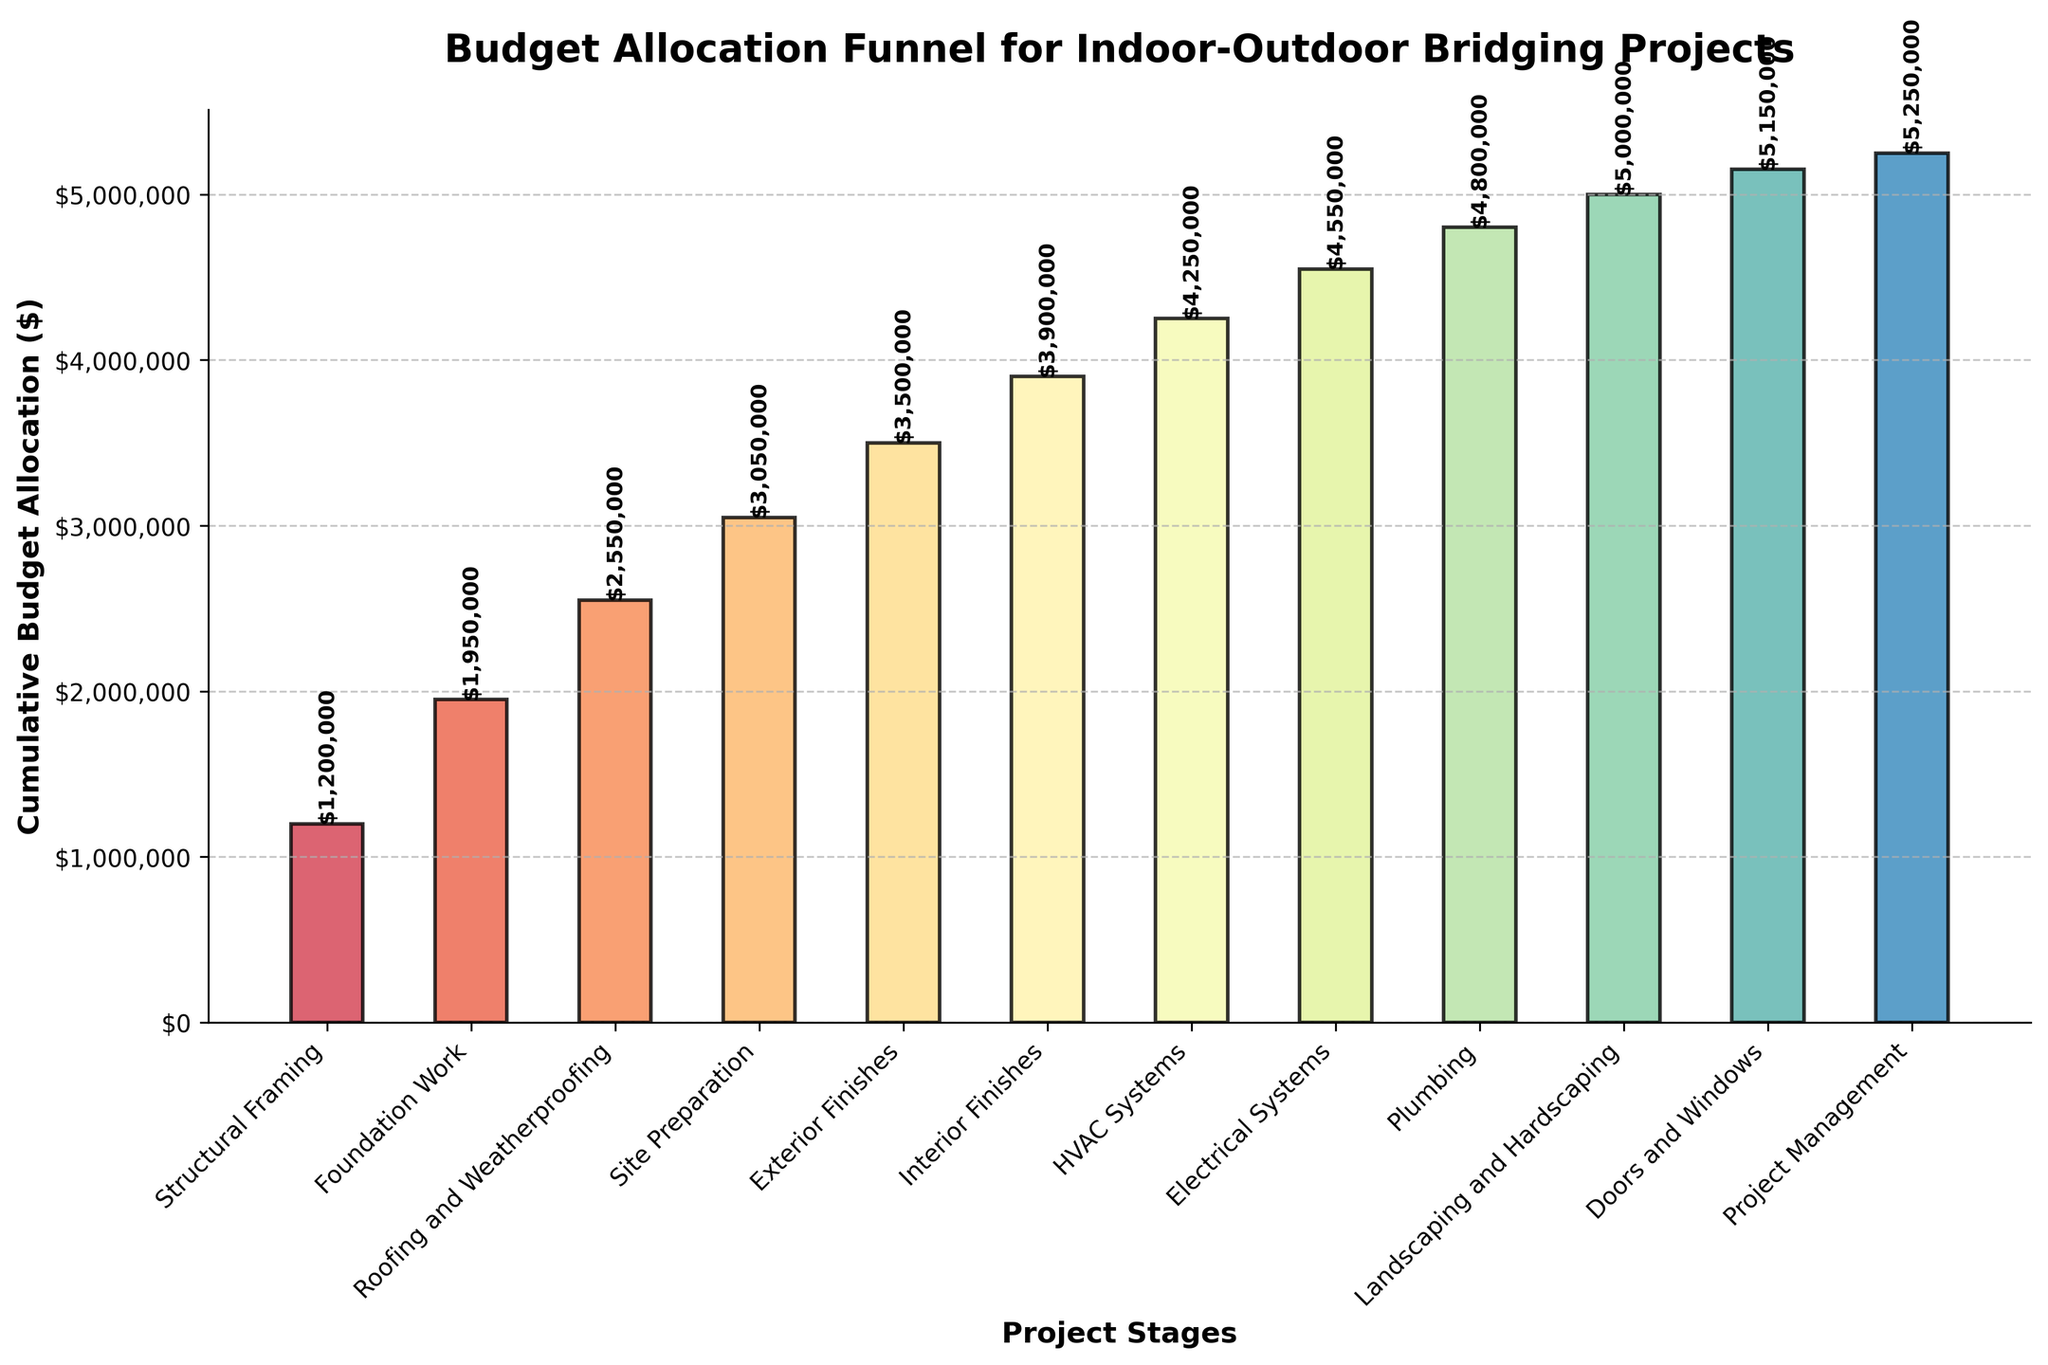What stage has the highest budget allocation? The stage with the highest budget allocation will be the first one in the sorted descending order list. From the figure, this stage is "Structural Framing".
Answer: Structural Framing What is the total budget allocation by the end of the HVAC Systems stage? To find this, sum up the cumulative budget allocations up to and including the HVAC Systems stage as represented in the bar for HVAC Systems. This sum is evident from the corresponding cumulative budget value.
Answer: $4,300,000 How does the budget allocation for Roofing and Weatherproofing compare to that for Exterior Finishes? The budget allocation for Roofing and Weatherproofing is wider and occurs earlier in the bar chart than the Exterior Finishes, indicating a higher amount.
Answer: Roofing and Weatherproofing is higher What is the title of this funnel chart? The title is displayed at the top of the chart; it reads "Budget Allocation Funnel for Indoor-Outdoor Bridging Projects".
Answer: Budget Allocation Funnel for Indoor-Outdoor Bridging Projects Which stage has the least budget allocation and what is its value? The stage with the least budget allocation is the one with the smallest bar at the bottom of the funnel, "Project Management", which has its cumulative value directly indicated in the bar text.
Answer: Project Management, $100,000 What is the cumulative budget allocation at the end of the Interior Finishes stage? Look at the cumulative budget indicated on the chart where the Interior Finishes stage bar is located. Identify the corresponding amount.
Answer: $3,900,000 How many stages are included in this budget allocation funnel? Count the number of distinct stages represented by bars in the funnel chart.
Answer: 12 By how much does the budget allocation for the Foundation Work stage exceed that for the Site Preparation stage? Subtract the budget allocation for the Site Preparation stage from that for the Foundation Work stage. The budgets are clearly indicated in the figure.
Answer: $250,000 Which stage follows after the highest budget allocation stage in the sequence? The stage that follows after "Structural Framing" (the highest budget allocation) in the descending sequence is "Foundation Work".
Answer: Foundation Work 